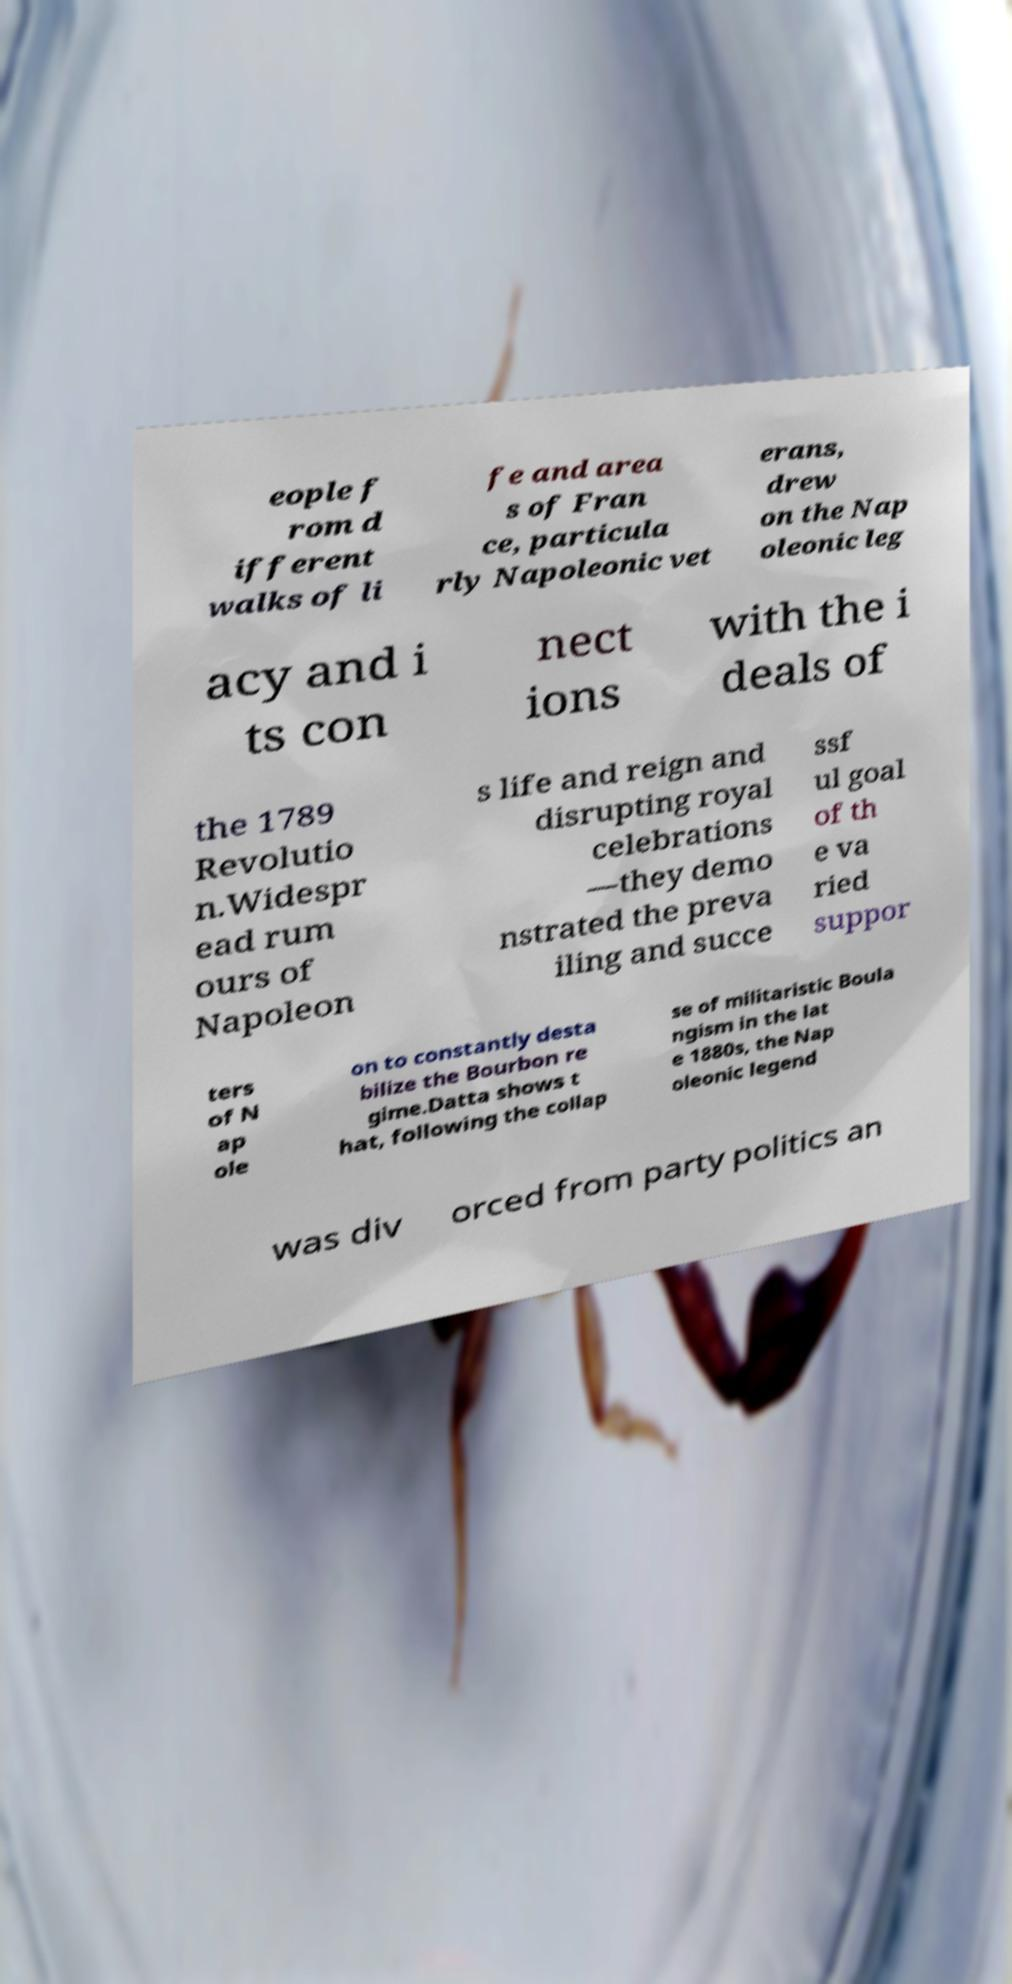Can you accurately transcribe the text from the provided image for me? eople f rom d ifferent walks of li fe and area s of Fran ce, particula rly Napoleonic vet erans, drew on the Nap oleonic leg acy and i ts con nect ions with the i deals of the 1789 Revolutio n.Widespr ead rum ours of Napoleon s life and reign and disrupting royal celebrations —they demo nstrated the preva iling and succe ssf ul goal of th e va ried suppor ters of N ap ole on to constantly desta bilize the Bourbon re gime.Datta shows t hat, following the collap se of militaristic Boula ngism in the lat e 1880s, the Nap oleonic legend was div orced from party politics an 